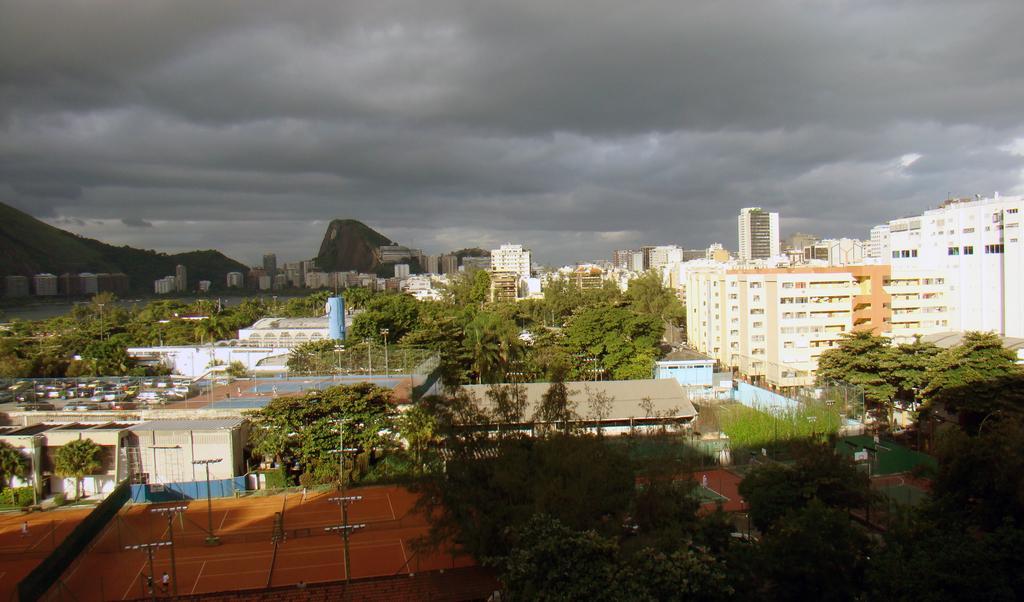Can you describe this image briefly? In this picture can see there are poles, trees and buildings. Behind the buildings there are hills and a cloudy sky. 